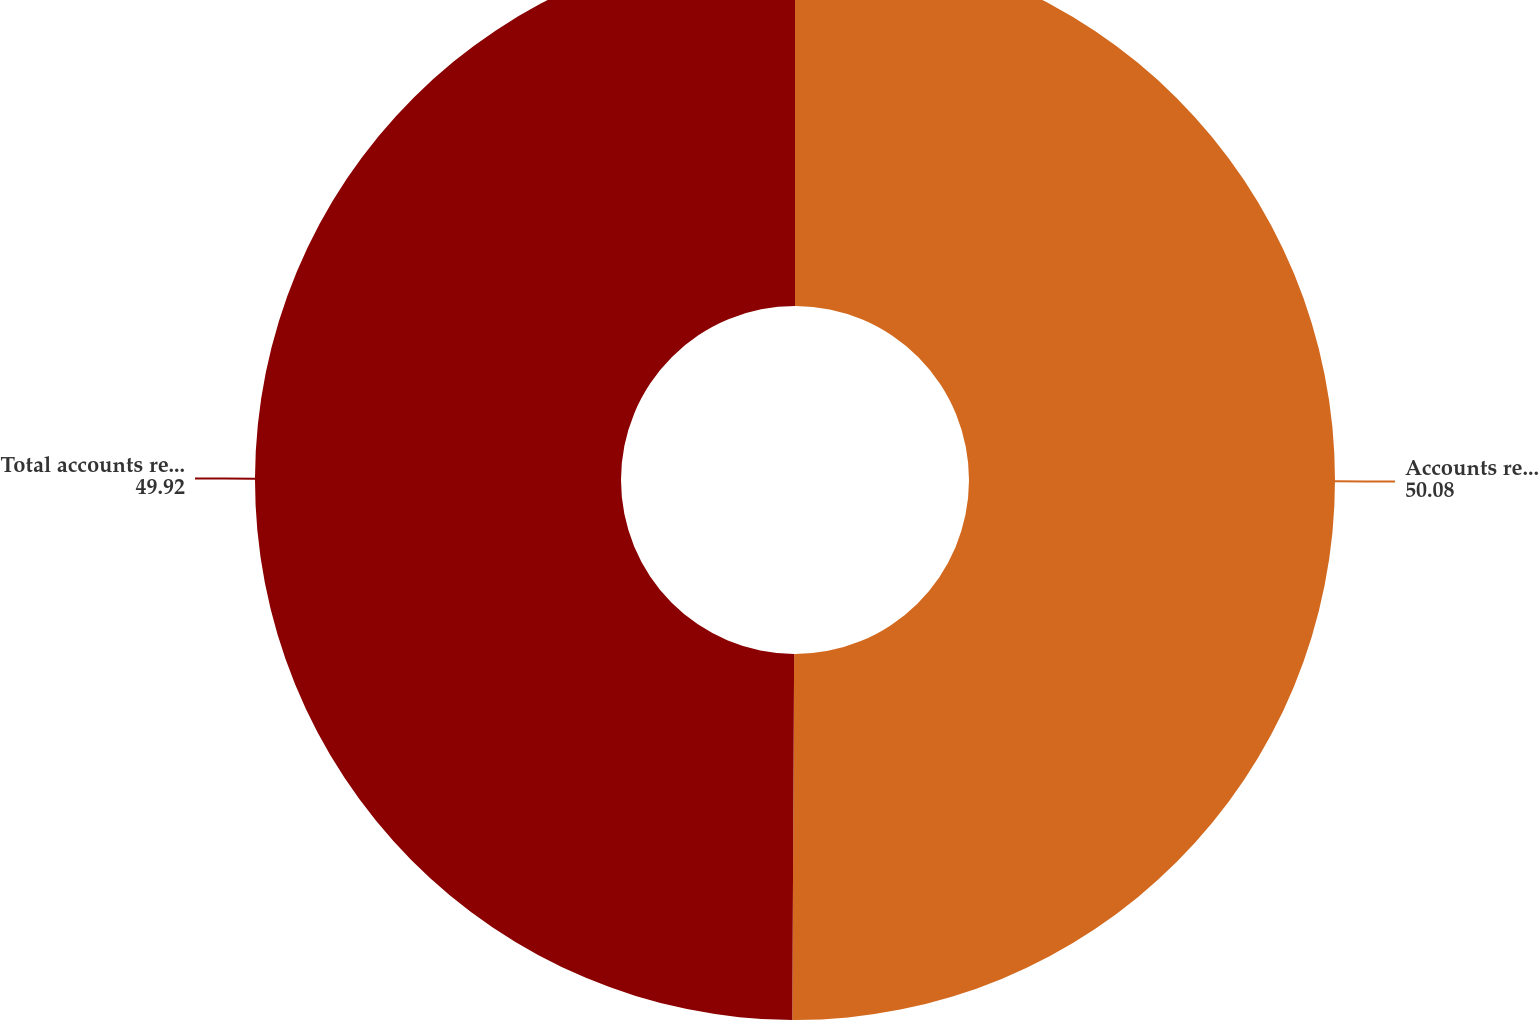Convert chart to OTSL. <chart><loc_0><loc_0><loc_500><loc_500><pie_chart><fcel>Accounts receivable<fcel>Total accounts receivable net<nl><fcel>50.08%<fcel>49.92%<nl></chart> 